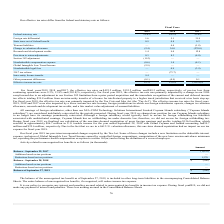From Macom Technology's financial document, What was the respective effective income tax rate in 2019, 2018 and 2017? The document contains multiple relevant values: 9.3%, 13.8%, (203.8)%. From the document: "Effective income tax rate 9.3% 13.8% (203.8)% Effective income tax rate 9.3% 13.8% (203.8)% Effective income tax rate 9.3% 13.8% (203.8)%..." Also, What was the respective foreign rate differential in 2019, 2018 and 2017? The document contains multiple relevant values: 1.6, 5.1, 31.9 (percentage). From the document: "Foreign rate differential 1.6 5.1 31.9 Foreign rate differential 1.6 5.1 31.9 Foreign rate differential 1.6 5.1 31.9..." Also, What was the Federal statutory rate in 2019? According to the financial document, 21.0 (percentage). The relevant text states: "Federal statutory rate 21.0% 24.5% 35.0%..." Additionally, In which year was Foreign rate differential greater than 10.0? According to the financial document, 2017. The relevant text states: "2019 2018 2017..." Also, can you calculate: What was the average State taxes net of federal benefit for 2017-2019? To answer this question, I need to perform calculations using the financial data. The calculation is: (0.9 + 0.8 + 0.2) / 3, which equals 0.63 (percentage). This is based on the information: "State taxes net of federal benefit 0.9 0.8 0.2 State taxes net of federal benefit 0.9 0.8 0.2 State taxes net of federal benefit 0.9 0.8 0.2..." The key data points involved are: 0.2, 0.8, 0.9. Also, can you calculate: What is the change in the Research and development credits from 2018 to 2019? Based on the calculation: 1.4 - 9.0, the result is -7.6 (percentage). This is based on the information: "Research and development credits 1.4 9.0 12.8 Research and development credits 1.4 9.0 12.8..." The key data points involved are: 1.4, 9.0. 